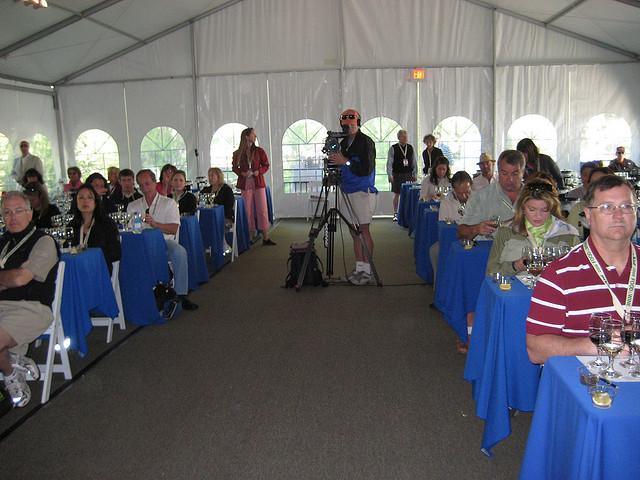Is this a formal event?
Short answer required. No. What are the event's theme colors?
Short answer required. Blue. What is the man in the center aisle doing?
Write a very short answer. Videoing. What are all these people doing?
Concise answer only. Eating. 